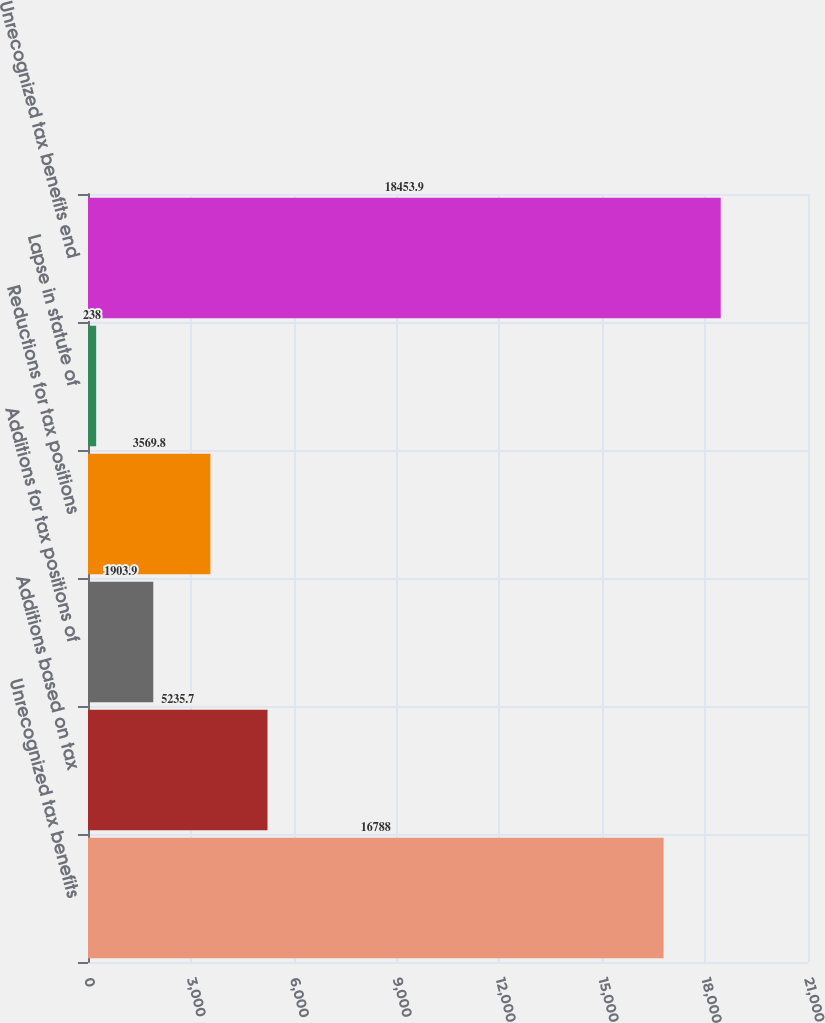Convert chart to OTSL. <chart><loc_0><loc_0><loc_500><loc_500><bar_chart><fcel>Unrecognized tax benefits<fcel>Additions based on tax<fcel>Additions for tax positions of<fcel>Reductions for tax positions<fcel>Lapse in statute of<fcel>Unrecognized tax benefits end<nl><fcel>16788<fcel>5235.7<fcel>1903.9<fcel>3569.8<fcel>238<fcel>18453.9<nl></chart> 